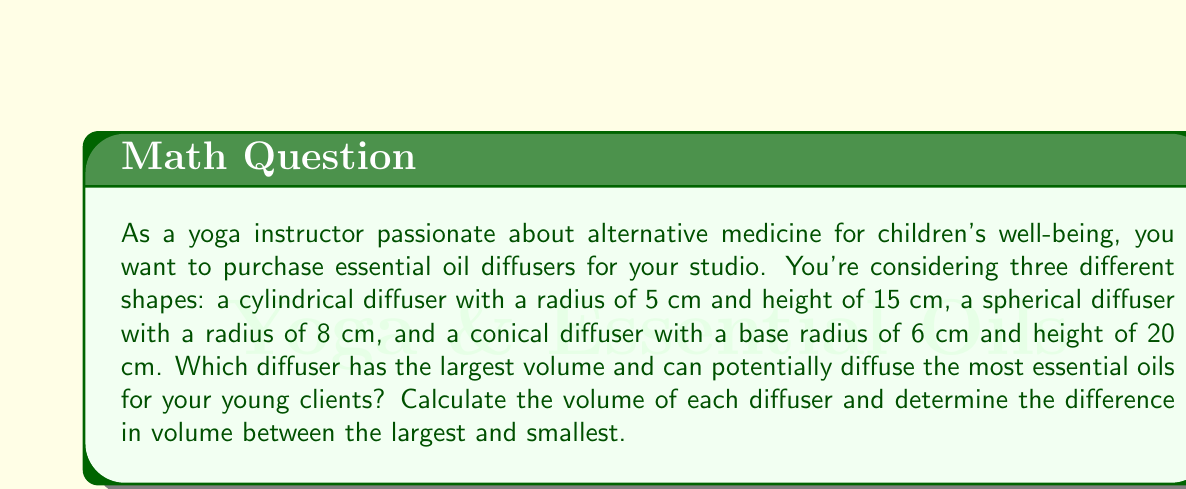Could you help me with this problem? Let's calculate the volume of each diffuser:

1. Cylindrical diffuser:
   Volume of a cylinder is given by $V = \pi r^2 h$
   $V_{cylinder} = \pi \cdot 5^2 \cdot 15 = 375\pi$ cm³

2. Spherical diffuser:
   Volume of a sphere is given by $V = \frac{4}{3}\pi r^3$
   $V_{sphere} = \frac{4}{3}\pi \cdot 8^3 = \frac{2048\pi}{3}$ cm³

3. Conical diffuser:
   Volume of a cone is given by $V = \frac{1}{3}\pi r^2 h$
   $V_{cone} = \frac{1}{3}\pi \cdot 6^2 \cdot 20 = 240\pi$ cm³

Now, let's compare the volumes:

$V_{cylinder} = 375\pi \approx 1178.10$ cm³
$V_{sphere} = \frac{2048\pi}{3} \approx 2145.66$ cm³
$V_{cone} = 240\pi \approx 753.98$ cm³

The spherical diffuser has the largest volume, while the conical diffuser has the smallest.

The difference in volume between the largest (sphere) and smallest (cone) is:

$\frac{2048\pi}{3} - 240\pi = \frac{2048\pi - 720\pi}{3} = \frac{1328\pi}{3} \approx 1391.68$ cm³
Answer: The spherical diffuser has the largest volume at approximately 2145.66 cm³. The difference in volume between the largest (spherical) and smallest (conical) diffuser is approximately 1391.68 cm³. 